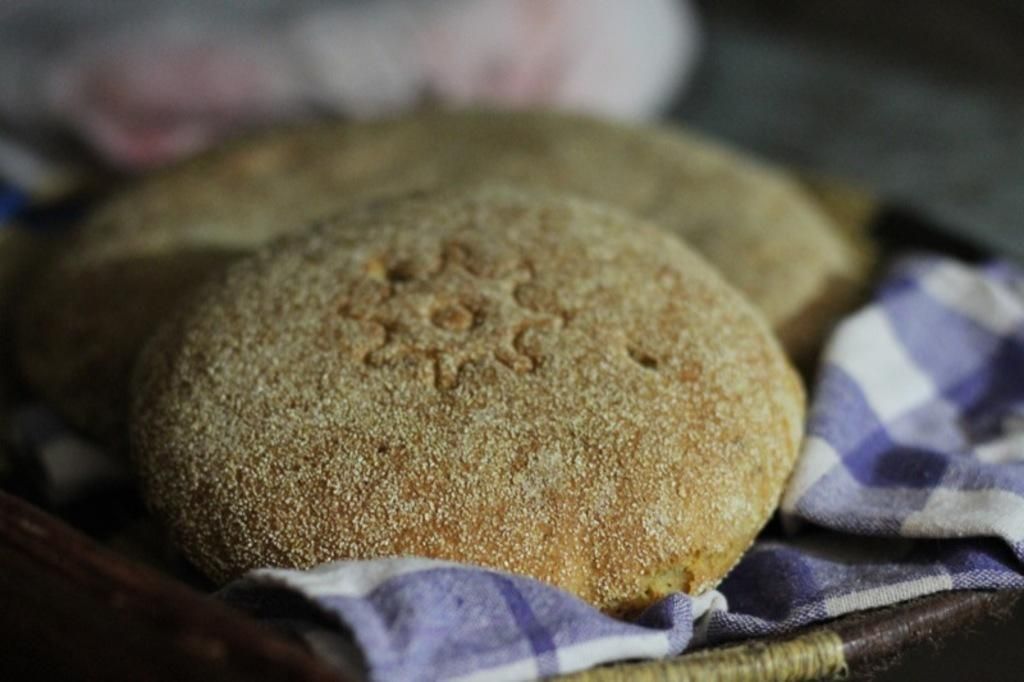What is in the foreground of the image? There are cookies in the foreground of the image. What is the cookies resting on? The cookies are on a cloth. What might be supporting the cloth in the image? The cloth appears to be on a tray. Can you describe the background of the image? The background of the image is blurred. What type of weather can be seen in the image? There is no indication of weather in the image, as it focuses on the cookies and their surroundings. 